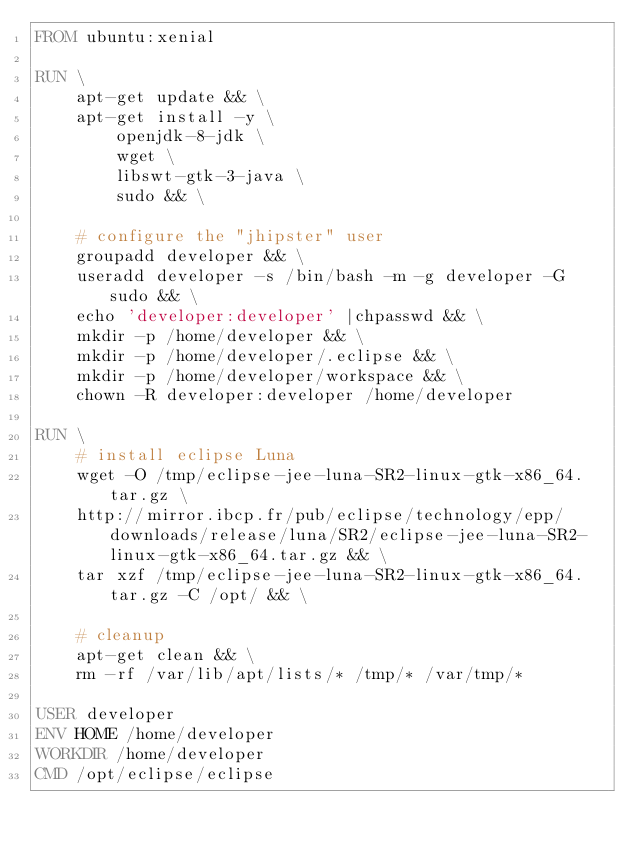Convert code to text. <code><loc_0><loc_0><loc_500><loc_500><_Dockerfile_>FROM ubuntu:xenial

RUN \
    apt-get update && \
    apt-get install -y \
        openjdk-8-jdk \
        wget \
        libswt-gtk-3-java \
        sudo && \

    # configure the "jhipster" user
    groupadd developer && \
    useradd developer -s /bin/bash -m -g developer -G sudo && \
    echo 'developer:developer' |chpasswd && \
    mkdir -p /home/developer && \
    mkdir -p /home/developer/.eclipse && \
    mkdir -p /home/developer/workspace && \
    chown -R developer:developer /home/developer

RUN \
    # install eclipse Luna
    wget -O /tmp/eclipse-jee-luna-SR2-linux-gtk-x86_64.tar.gz \
    http://mirror.ibcp.fr/pub/eclipse/technology/epp/downloads/release/luna/SR2/eclipse-jee-luna-SR2-linux-gtk-x86_64.tar.gz && \
    tar xzf /tmp/eclipse-jee-luna-SR2-linux-gtk-x86_64.tar.gz -C /opt/ && \

    # cleanup
    apt-get clean && \
    rm -rf /var/lib/apt/lists/* /tmp/* /var/tmp/*

USER developer
ENV HOME /home/developer
WORKDIR /home/developer
CMD /opt/eclipse/eclipse
</code> 